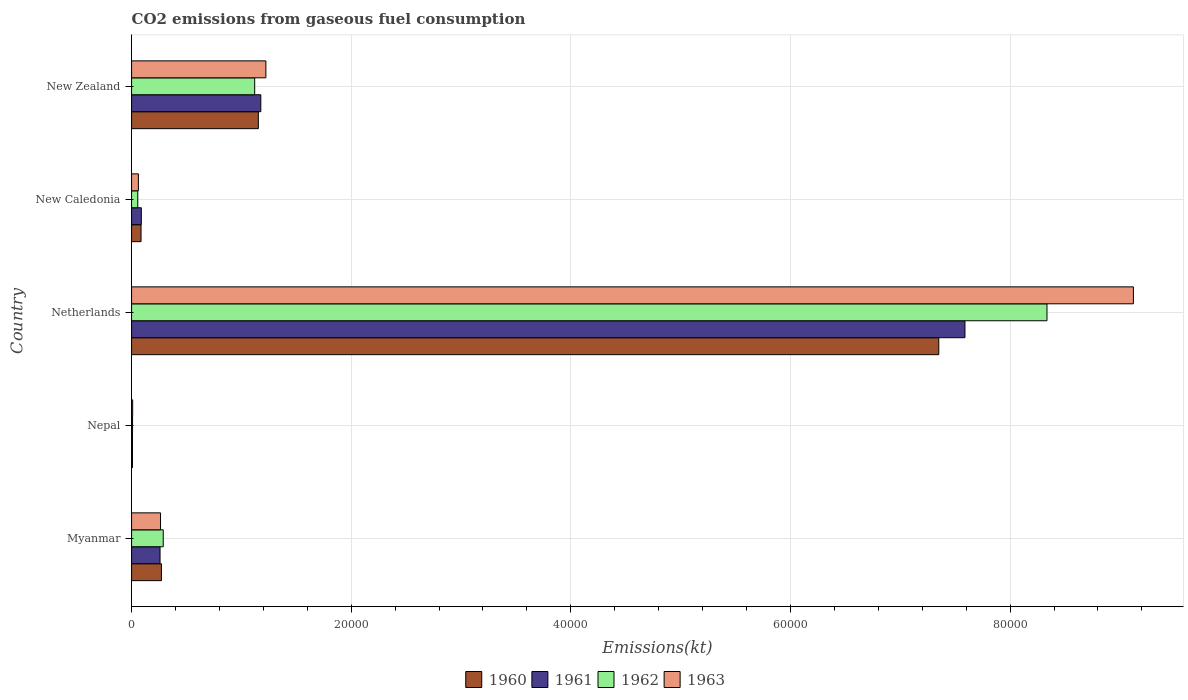How many groups of bars are there?
Ensure brevity in your answer.  5. Are the number of bars on each tick of the Y-axis equal?
Your answer should be compact. Yes. What is the label of the 4th group of bars from the top?
Offer a terse response. Nepal. What is the amount of CO2 emitted in 1963 in Nepal?
Keep it short and to the point. 99.01. Across all countries, what is the maximum amount of CO2 emitted in 1962?
Offer a very short reply. 8.34e+04. Across all countries, what is the minimum amount of CO2 emitted in 1961?
Your answer should be very brief. 80.67. In which country was the amount of CO2 emitted in 1962 maximum?
Your response must be concise. Netherlands. In which country was the amount of CO2 emitted in 1960 minimum?
Your answer should be compact. Nepal. What is the total amount of CO2 emitted in 1960 in the graph?
Your response must be concise. 8.87e+04. What is the difference between the amount of CO2 emitted in 1960 in Myanmar and that in Nepal?
Make the answer very short. 2636.57. What is the difference between the amount of CO2 emitted in 1963 in New Zealand and the amount of CO2 emitted in 1961 in New Caledonia?
Your response must be concise. 1.13e+04. What is the average amount of CO2 emitted in 1962 per country?
Offer a terse response. 1.96e+04. What is the difference between the amount of CO2 emitted in 1962 and amount of CO2 emitted in 1961 in Myanmar?
Your answer should be compact. 289.69. What is the ratio of the amount of CO2 emitted in 1961 in New Caledonia to that in New Zealand?
Provide a succinct answer. 0.08. Is the difference between the amount of CO2 emitted in 1962 in Netherlands and New Caledonia greater than the difference between the amount of CO2 emitted in 1961 in Netherlands and New Caledonia?
Your answer should be very brief. Yes. What is the difference between the highest and the second highest amount of CO2 emitted in 1963?
Your response must be concise. 7.90e+04. What is the difference between the highest and the lowest amount of CO2 emitted in 1963?
Ensure brevity in your answer.  9.11e+04. In how many countries, is the amount of CO2 emitted in 1962 greater than the average amount of CO2 emitted in 1962 taken over all countries?
Make the answer very short. 1. Is the sum of the amount of CO2 emitted in 1960 in New Caledonia and New Zealand greater than the maximum amount of CO2 emitted in 1961 across all countries?
Provide a short and direct response. No. What does the 1st bar from the bottom in New Zealand represents?
Keep it short and to the point. 1960. How many countries are there in the graph?
Make the answer very short. 5. What is the difference between two consecutive major ticks on the X-axis?
Provide a short and direct response. 2.00e+04. Does the graph contain any zero values?
Your answer should be very brief. No. How many legend labels are there?
Keep it short and to the point. 4. How are the legend labels stacked?
Provide a short and direct response. Horizontal. What is the title of the graph?
Offer a terse response. CO2 emissions from gaseous fuel consumption. What is the label or title of the X-axis?
Your response must be concise. Emissions(kt). What is the label or title of the Y-axis?
Your answer should be very brief. Country. What is the Emissions(kt) in 1960 in Myanmar?
Your response must be concise. 2717.25. What is the Emissions(kt) of 1961 in Myanmar?
Ensure brevity in your answer.  2592.57. What is the Emissions(kt) of 1962 in Myanmar?
Your answer should be compact. 2882.26. What is the Emissions(kt) of 1963 in Myanmar?
Your answer should be compact. 2636.57. What is the Emissions(kt) of 1960 in Nepal?
Provide a short and direct response. 80.67. What is the Emissions(kt) in 1961 in Nepal?
Provide a succinct answer. 80.67. What is the Emissions(kt) of 1962 in Nepal?
Your answer should be compact. 88.01. What is the Emissions(kt) of 1963 in Nepal?
Provide a short and direct response. 99.01. What is the Emissions(kt) in 1960 in Netherlands?
Your response must be concise. 7.35e+04. What is the Emissions(kt) of 1961 in Netherlands?
Provide a succinct answer. 7.59e+04. What is the Emissions(kt) of 1962 in Netherlands?
Provide a succinct answer. 8.34e+04. What is the Emissions(kt) in 1963 in Netherlands?
Provide a short and direct response. 9.12e+04. What is the Emissions(kt) of 1960 in New Caledonia?
Ensure brevity in your answer.  861.75. What is the Emissions(kt) in 1961 in New Caledonia?
Your answer should be compact. 887.41. What is the Emissions(kt) in 1962 in New Caledonia?
Offer a very short reply. 564.72. What is the Emissions(kt) of 1963 in New Caledonia?
Provide a succinct answer. 619.72. What is the Emissions(kt) in 1960 in New Zealand?
Provide a succinct answer. 1.15e+04. What is the Emissions(kt) in 1961 in New Zealand?
Your answer should be compact. 1.18e+04. What is the Emissions(kt) of 1962 in New Zealand?
Your response must be concise. 1.12e+04. What is the Emissions(kt) in 1963 in New Zealand?
Offer a very short reply. 1.22e+04. Across all countries, what is the maximum Emissions(kt) in 1960?
Give a very brief answer. 7.35e+04. Across all countries, what is the maximum Emissions(kt) of 1961?
Your answer should be very brief. 7.59e+04. Across all countries, what is the maximum Emissions(kt) of 1962?
Make the answer very short. 8.34e+04. Across all countries, what is the maximum Emissions(kt) of 1963?
Provide a short and direct response. 9.12e+04. Across all countries, what is the minimum Emissions(kt) in 1960?
Make the answer very short. 80.67. Across all countries, what is the minimum Emissions(kt) in 1961?
Your answer should be compact. 80.67. Across all countries, what is the minimum Emissions(kt) of 1962?
Offer a very short reply. 88.01. Across all countries, what is the minimum Emissions(kt) in 1963?
Ensure brevity in your answer.  99.01. What is the total Emissions(kt) of 1960 in the graph?
Your answer should be compact. 8.87e+04. What is the total Emissions(kt) of 1961 in the graph?
Your answer should be very brief. 9.12e+04. What is the total Emissions(kt) of 1962 in the graph?
Provide a short and direct response. 9.81e+04. What is the total Emissions(kt) of 1963 in the graph?
Your answer should be compact. 1.07e+05. What is the difference between the Emissions(kt) of 1960 in Myanmar and that in Nepal?
Give a very brief answer. 2636.57. What is the difference between the Emissions(kt) of 1961 in Myanmar and that in Nepal?
Ensure brevity in your answer.  2511.89. What is the difference between the Emissions(kt) in 1962 in Myanmar and that in Nepal?
Your answer should be very brief. 2794.25. What is the difference between the Emissions(kt) of 1963 in Myanmar and that in Nepal?
Your response must be concise. 2537.56. What is the difference between the Emissions(kt) in 1960 in Myanmar and that in Netherlands?
Keep it short and to the point. -7.08e+04. What is the difference between the Emissions(kt) in 1961 in Myanmar and that in Netherlands?
Ensure brevity in your answer.  -7.33e+04. What is the difference between the Emissions(kt) in 1962 in Myanmar and that in Netherlands?
Your answer should be compact. -8.05e+04. What is the difference between the Emissions(kt) of 1963 in Myanmar and that in Netherlands?
Give a very brief answer. -8.86e+04. What is the difference between the Emissions(kt) in 1960 in Myanmar and that in New Caledonia?
Offer a terse response. 1855.5. What is the difference between the Emissions(kt) in 1961 in Myanmar and that in New Caledonia?
Offer a terse response. 1705.15. What is the difference between the Emissions(kt) of 1962 in Myanmar and that in New Caledonia?
Offer a terse response. 2317.54. What is the difference between the Emissions(kt) in 1963 in Myanmar and that in New Caledonia?
Your answer should be very brief. 2016.85. What is the difference between the Emissions(kt) of 1960 in Myanmar and that in New Zealand?
Your answer should be compact. -8826.47. What is the difference between the Emissions(kt) in 1961 in Myanmar and that in New Zealand?
Your response must be concise. -9174.83. What is the difference between the Emissions(kt) of 1962 in Myanmar and that in New Zealand?
Give a very brief answer. -8327.76. What is the difference between the Emissions(kt) of 1963 in Myanmar and that in New Zealand?
Ensure brevity in your answer.  -9592.87. What is the difference between the Emissions(kt) in 1960 in Nepal and that in Netherlands?
Your response must be concise. -7.34e+04. What is the difference between the Emissions(kt) in 1961 in Nepal and that in Netherlands?
Ensure brevity in your answer.  -7.58e+04. What is the difference between the Emissions(kt) of 1962 in Nepal and that in Netherlands?
Provide a succinct answer. -8.33e+04. What is the difference between the Emissions(kt) in 1963 in Nepal and that in Netherlands?
Your answer should be very brief. -9.11e+04. What is the difference between the Emissions(kt) in 1960 in Nepal and that in New Caledonia?
Make the answer very short. -781.07. What is the difference between the Emissions(kt) of 1961 in Nepal and that in New Caledonia?
Your response must be concise. -806.74. What is the difference between the Emissions(kt) of 1962 in Nepal and that in New Caledonia?
Your response must be concise. -476.71. What is the difference between the Emissions(kt) of 1963 in Nepal and that in New Caledonia?
Your answer should be very brief. -520.71. What is the difference between the Emissions(kt) in 1960 in Nepal and that in New Zealand?
Make the answer very short. -1.15e+04. What is the difference between the Emissions(kt) of 1961 in Nepal and that in New Zealand?
Ensure brevity in your answer.  -1.17e+04. What is the difference between the Emissions(kt) of 1962 in Nepal and that in New Zealand?
Your answer should be compact. -1.11e+04. What is the difference between the Emissions(kt) of 1963 in Nepal and that in New Zealand?
Ensure brevity in your answer.  -1.21e+04. What is the difference between the Emissions(kt) of 1960 in Netherlands and that in New Caledonia?
Offer a terse response. 7.26e+04. What is the difference between the Emissions(kt) in 1961 in Netherlands and that in New Caledonia?
Give a very brief answer. 7.50e+04. What is the difference between the Emissions(kt) of 1962 in Netherlands and that in New Caledonia?
Keep it short and to the point. 8.28e+04. What is the difference between the Emissions(kt) in 1963 in Netherlands and that in New Caledonia?
Offer a terse response. 9.06e+04. What is the difference between the Emissions(kt) in 1960 in Netherlands and that in New Zealand?
Your answer should be compact. 6.20e+04. What is the difference between the Emissions(kt) in 1961 in Netherlands and that in New Zealand?
Your answer should be very brief. 6.41e+04. What is the difference between the Emissions(kt) in 1962 in Netherlands and that in New Zealand?
Provide a short and direct response. 7.21e+04. What is the difference between the Emissions(kt) of 1963 in Netherlands and that in New Zealand?
Your response must be concise. 7.90e+04. What is the difference between the Emissions(kt) in 1960 in New Caledonia and that in New Zealand?
Offer a very short reply. -1.07e+04. What is the difference between the Emissions(kt) in 1961 in New Caledonia and that in New Zealand?
Provide a succinct answer. -1.09e+04. What is the difference between the Emissions(kt) of 1962 in New Caledonia and that in New Zealand?
Offer a very short reply. -1.06e+04. What is the difference between the Emissions(kt) in 1963 in New Caledonia and that in New Zealand?
Offer a very short reply. -1.16e+04. What is the difference between the Emissions(kt) of 1960 in Myanmar and the Emissions(kt) of 1961 in Nepal?
Provide a succinct answer. 2636.57. What is the difference between the Emissions(kt) of 1960 in Myanmar and the Emissions(kt) of 1962 in Nepal?
Provide a short and direct response. 2629.24. What is the difference between the Emissions(kt) in 1960 in Myanmar and the Emissions(kt) in 1963 in Nepal?
Your answer should be compact. 2618.24. What is the difference between the Emissions(kt) in 1961 in Myanmar and the Emissions(kt) in 1962 in Nepal?
Provide a succinct answer. 2504.56. What is the difference between the Emissions(kt) of 1961 in Myanmar and the Emissions(kt) of 1963 in Nepal?
Provide a short and direct response. 2493.56. What is the difference between the Emissions(kt) in 1962 in Myanmar and the Emissions(kt) in 1963 in Nepal?
Offer a very short reply. 2783.25. What is the difference between the Emissions(kt) of 1960 in Myanmar and the Emissions(kt) of 1961 in Netherlands?
Provide a short and direct response. -7.32e+04. What is the difference between the Emissions(kt) of 1960 in Myanmar and the Emissions(kt) of 1962 in Netherlands?
Your answer should be compact. -8.06e+04. What is the difference between the Emissions(kt) of 1960 in Myanmar and the Emissions(kt) of 1963 in Netherlands?
Ensure brevity in your answer.  -8.85e+04. What is the difference between the Emissions(kt) of 1961 in Myanmar and the Emissions(kt) of 1962 in Netherlands?
Offer a terse response. -8.08e+04. What is the difference between the Emissions(kt) in 1961 in Myanmar and the Emissions(kt) in 1963 in Netherlands?
Ensure brevity in your answer.  -8.86e+04. What is the difference between the Emissions(kt) in 1962 in Myanmar and the Emissions(kt) in 1963 in Netherlands?
Make the answer very short. -8.83e+04. What is the difference between the Emissions(kt) in 1960 in Myanmar and the Emissions(kt) in 1961 in New Caledonia?
Provide a succinct answer. 1829.83. What is the difference between the Emissions(kt) in 1960 in Myanmar and the Emissions(kt) in 1962 in New Caledonia?
Offer a very short reply. 2152.53. What is the difference between the Emissions(kt) of 1960 in Myanmar and the Emissions(kt) of 1963 in New Caledonia?
Offer a very short reply. 2097.52. What is the difference between the Emissions(kt) in 1961 in Myanmar and the Emissions(kt) in 1962 in New Caledonia?
Ensure brevity in your answer.  2027.85. What is the difference between the Emissions(kt) in 1961 in Myanmar and the Emissions(kt) in 1963 in New Caledonia?
Your response must be concise. 1972.85. What is the difference between the Emissions(kt) in 1962 in Myanmar and the Emissions(kt) in 1963 in New Caledonia?
Offer a very short reply. 2262.54. What is the difference between the Emissions(kt) in 1960 in Myanmar and the Emissions(kt) in 1961 in New Zealand?
Your response must be concise. -9050.16. What is the difference between the Emissions(kt) in 1960 in Myanmar and the Emissions(kt) in 1962 in New Zealand?
Keep it short and to the point. -8492.77. What is the difference between the Emissions(kt) in 1960 in Myanmar and the Emissions(kt) in 1963 in New Zealand?
Offer a very short reply. -9512.2. What is the difference between the Emissions(kt) of 1961 in Myanmar and the Emissions(kt) of 1962 in New Zealand?
Make the answer very short. -8617.45. What is the difference between the Emissions(kt) in 1961 in Myanmar and the Emissions(kt) in 1963 in New Zealand?
Offer a very short reply. -9636.88. What is the difference between the Emissions(kt) of 1962 in Myanmar and the Emissions(kt) of 1963 in New Zealand?
Offer a very short reply. -9347.18. What is the difference between the Emissions(kt) in 1960 in Nepal and the Emissions(kt) in 1961 in Netherlands?
Your response must be concise. -7.58e+04. What is the difference between the Emissions(kt) in 1960 in Nepal and the Emissions(kt) in 1962 in Netherlands?
Your answer should be very brief. -8.33e+04. What is the difference between the Emissions(kt) of 1960 in Nepal and the Emissions(kt) of 1963 in Netherlands?
Give a very brief answer. -9.11e+04. What is the difference between the Emissions(kt) of 1961 in Nepal and the Emissions(kt) of 1962 in Netherlands?
Provide a short and direct response. -8.33e+04. What is the difference between the Emissions(kt) of 1961 in Nepal and the Emissions(kt) of 1963 in Netherlands?
Provide a succinct answer. -9.11e+04. What is the difference between the Emissions(kt) in 1962 in Nepal and the Emissions(kt) in 1963 in Netherlands?
Provide a succinct answer. -9.11e+04. What is the difference between the Emissions(kt) in 1960 in Nepal and the Emissions(kt) in 1961 in New Caledonia?
Your answer should be compact. -806.74. What is the difference between the Emissions(kt) in 1960 in Nepal and the Emissions(kt) in 1962 in New Caledonia?
Make the answer very short. -484.04. What is the difference between the Emissions(kt) in 1960 in Nepal and the Emissions(kt) in 1963 in New Caledonia?
Ensure brevity in your answer.  -539.05. What is the difference between the Emissions(kt) in 1961 in Nepal and the Emissions(kt) in 1962 in New Caledonia?
Your answer should be very brief. -484.04. What is the difference between the Emissions(kt) of 1961 in Nepal and the Emissions(kt) of 1963 in New Caledonia?
Offer a very short reply. -539.05. What is the difference between the Emissions(kt) in 1962 in Nepal and the Emissions(kt) in 1963 in New Caledonia?
Provide a succinct answer. -531.72. What is the difference between the Emissions(kt) of 1960 in Nepal and the Emissions(kt) of 1961 in New Zealand?
Offer a very short reply. -1.17e+04. What is the difference between the Emissions(kt) of 1960 in Nepal and the Emissions(kt) of 1962 in New Zealand?
Your answer should be very brief. -1.11e+04. What is the difference between the Emissions(kt) of 1960 in Nepal and the Emissions(kt) of 1963 in New Zealand?
Your response must be concise. -1.21e+04. What is the difference between the Emissions(kt) of 1961 in Nepal and the Emissions(kt) of 1962 in New Zealand?
Provide a succinct answer. -1.11e+04. What is the difference between the Emissions(kt) of 1961 in Nepal and the Emissions(kt) of 1963 in New Zealand?
Keep it short and to the point. -1.21e+04. What is the difference between the Emissions(kt) in 1962 in Nepal and the Emissions(kt) in 1963 in New Zealand?
Keep it short and to the point. -1.21e+04. What is the difference between the Emissions(kt) in 1960 in Netherlands and the Emissions(kt) in 1961 in New Caledonia?
Your response must be concise. 7.26e+04. What is the difference between the Emissions(kt) in 1960 in Netherlands and the Emissions(kt) in 1962 in New Caledonia?
Provide a succinct answer. 7.29e+04. What is the difference between the Emissions(kt) in 1960 in Netherlands and the Emissions(kt) in 1963 in New Caledonia?
Your response must be concise. 7.29e+04. What is the difference between the Emissions(kt) in 1961 in Netherlands and the Emissions(kt) in 1962 in New Caledonia?
Ensure brevity in your answer.  7.53e+04. What is the difference between the Emissions(kt) of 1961 in Netherlands and the Emissions(kt) of 1963 in New Caledonia?
Keep it short and to the point. 7.53e+04. What is the difference between the Emissions(kt) in 1962 in Netherlands and the Emissions(kt) in 1963 in New Caledonia?
Your answer should be very brief. 8.27e+04. What is the difference between the Emissions(kt) in 1960 in Netherlands and the Emissions(kt) in 1961 in New Zealand?
Offer a very short reply. 6.17e+04. What is the difference between the Emissions(kt) of 1960 in Netherlands and the Emissions(kt) of 1962 in New Zealand?
Your answer should be very brief. 6.23e+04. What is the difference between the Emissions(kt) of 1960 in Netherlands and the Emissions(kt) of 1963 in New Zealand?
Offer a very short reply. 6.13e+04. What is the difference between the Emissions(kt) in 1961 in Netherlands and the Emissions(kt) in 1962 in New Zealand?
Offer a terse response. 6.47e+04. What is the difference between the Emissions(kt) in 1961 in Netherlands and the Emissions(kt) in 1963 in New Zealand?
Your answer should be compact. 6.37e+04. What is the difference between the Emissions(kt) in 1962 in Netherlands and the Emissions(kt) in 1963 in New Zealand?
Your answer should be very brief. 7.11e+04. What is the difference between the Emissions(kt) of 1960 in New Caledonia and the Emissions(kt) of 1961 in New Zealand?
Keep it short and to the point. -1.09e+04. What is the difference between the Emissions(kt) in 1960 in New Caledonia and the Emissions(kt) in 1962 in New Zealand?
Your answer should be compact. -1.03e+04. What is the difference between the Emissions(kt) of 1960 in New Caledonia and the Emissions(kt) of 1963 in New Zealand?
Provide a succinct answer. -1.14e+04. What is the difference between the Emissions(kt) of 1961 in New Caledonia and the Emissions(kt) of 1962 in New Zealand?
Provide a succinct answer. -1.03e+04. What is the difference between the Emissions(kt) of 1961 in New Caledonia and the Emissions(kt) of 1963 in New Zealand?
Offer a very short reply. -1.13e+04. What is the difference between the Emissions(kt) in 1962 in New Caledonia and the Emissions(kt) in 1963 in New Zealand?
Make the answer very short. -1.17e+04. What is the average Emissions(kt) in 1960 per country?
Keep it short and to the point. 1.77e+04. What is the average Emissions(kt) of 1961 per country?
Offer a terse response. 1.82e+04. What is the average Emissions(kt) in 1962 per country?
Your answer should be very brief. 1.96e+04. What is the average Emissions(kt) of 1963 per country?
Provide a short and direct response. 2.14e+04. What is the difference between the Emissions(kt) of 1960 and Emissions(kt) of 1961 in Myanmar?
Offer a very short reply. 124.68. What is the difference between the Emissions(kt) in 1960 and Emissions(kt) in 1962 in Myanmar?
Make the answer very short. -165.01. What is the difference between the Emissions(kt) of 1960 and Emissions(kt) of 1963 in Myanmar?
Your answer should be very brief. 80.67. What is the difference between the Emissions(kt) in 1961 and Emissions(kt) in 1962 in Myanmar?
Offer a terse response. -289.69. What is the difference between the Emissions(kt) of 1961 and Emissions(kt) of 1963 in Myanmar?
Offer a very short reply. -44. What is the difference between the Emissions(kt) in 1962 and Emissions(kt) in 1963 in Myanmar?
Offer a very short reply. 245.69. What is the difference between the Emissions(kt) in 1960 and Emissions(kt) in 1961 in Nepal?
Offer a very short reply. 0. What is the difference between the Emissions(kt) in 1960 and Emissions(kt) in 1962 in Nepal?
Ensure brevity in your answer.  -7.33. What is the difference between the Emissions(kt) of 1960 and Emissions(kt) of 1963 in Nepal?
Provide a short and direct response. -18.34. What is the difference between the Emissions(kt) of 1961 and Emissions(kt) of 1962 in Nepal?
Give a very brief answer. -7.33. What is the difference between the Emissions(kt) of 1961 and Emissions(kt) of 1963 in Nepal?
Your response must be concise. -18.34. What is the difference between the Emissions(kt) of 1962 and Emissions(kt) of 1963 in Nepal?
Give a very brief answer. -11. What is the difference between the Emissions(kt) in 1960 and Emissions(kt) in 1961 in Netherlands?
Your response must be concise. -2383.55. What is the difference between the Emissions(kt) of 1960 and Emissions(kt) of 1962 in Netherlands?
Give a very brief answer. -9853.23. What is the difference between the Emissions(kt) in 1960 and Emissions(kt) in 1963 in Netherlands?
Provide a succinct answer. -1.77e+04. What is the difference between the Emissions(kt) of 1961 and Emissions(kt) of 1962 in Netherlands?
Your response must be concise. -7469.68. What is the difference between the Emissions(kt) of 1961 and Emissions(kt) of 1963 in Netherlands?
Give a very brief answer. -1.53e+04. What is the difference between the Emissions(kt) of 1962 and Emissions(kt) of 1963 in Netherlands?
Offer a terse response. -7869.38. What is the difference between the Emissions(kt) of 1960 and Emissions(kt) of 1961 in New Caledonia?
Ensure brevity in your answer.  -25.67. What is the difference between the Emissions(kt) of 1960 and Emissions(kt) of 1962 in New Caledonia?
Make the answer very short. 297.03. What is the difference between the Emissions(kt) in 1960 and Emissions(kt) in 1963 in New Caledonia?
Offer a very short reply. 242.02. What is the difference between the Emissions(kt) of 1961 and Emissions(kt) of 1962 in New Caledonia?
Offer a terse response. 322.7. What is the difference between the Emissions(kt) in 1961 and Emissions(kt) in 1963 in New Caledonia?
Ensure brevity in your answer.  267.69. What is the difference between the Emissions(kt) in 1962 and Emissions(kt) in 1963 in New Caledonia?
Keep it short and to the point. -55.01. What is the difference between the Emissions(kt) in 1960 and Emissions(kt) in 1961 in New Zealand?
Keep it short and to the point. -223.69. What is the difference between the Emissions(kt) in 1960 and Emissions(kt) in 1962 in New Zealand?
Provide a short and direct response. 333.7. What is the difference between the Emissions(kt) of 1960 and Emissions(kt) of 1963 in New Zealand?
Offer a terse response. -685.73. What is the difference between the Emissions(kt) in 1961 and Emissions(kt) in 1962 in New Zealand?
Make the answer very short. 557.38. What is the difference between the Emissions(kt) of 1961 and Emissions(kt) of 1963 in New Zealand?
Keep it short and to the point. -462.04. What is the difference between the Emissions(kt) in 1962 and Emissions(kt) in 1963 in New Zealand?
Ensure brevity in your answer.  -1019.43. What is the ratio of the Emissions(kt) of 1960 in Myanmar to that in Nepal?
Provide a short and direct response. 33.68. What is the ratio of the Emissions(kt) of 1961 in Myanmar to that in Nepal?
Make the answer very short. 32.14. What is the ratio of the Emissions(kt) in 1962 in Myanmar to that in Nepal?
Your response must be concise. 32.75. What is the ratio of the Emissions(kt) in 1963 in Myanmar to that in Nepal?
Your response must be concise. 26.63. What is the ratio of the Emissions(kt) in 1960 in Myanmar to that in Netherlands?
Make the answer very short. 0.04. What is the ratio of the Emissions(kt) in 1961 in Myanmar to that in Netherlands?
Ensure brevity in your answer.  0.03. What is the ratio of the Emissions(kt) in 1962 in Myanmar to that in Netherlands?
Make the answer very short. 0.03. What is the ratio of the Emissions(kt) in 1963 in Myanmar to that in Netherlands?
Keep it short and to the point. 0.03. What is the ratio of the Emissions(kt) of 1960 in Myanmar to that in New Caledonia?
Your answer should be compact. 3.15. What is the ratio of the Emissions(kt) of 1961 in Myanmar to that in New Caledonia?
Provide a short and direct response. 2.92. What is the ratio of the Emissions(kt) of 1962 in Myanmar to that in New Caledonia?
Offer a very short reply. 5.1. What is the ratio of the Emissions(kt) in 1963 in Myanmar to that in New Caledonia?
Give a very brief answer. 4.25. What is the ratio of the Emissions(kt) in 1960 in Myanmar to that in New Zealand?
Offer a terse response. 0.24. What is the ratio of the Emissions(kt) in 1961 in Myanmar to that in New Zealand?
Keep it short and to the point. 0.22. What is the ratio of the Emissions(kt) in 1962 in Myanmar to that in New Zealand?
Make the answer very short. 0.26. What is the ratio of the Emissions(kt) in 1963 in Myanmar to that in New Zealand?
Give a very brief answer. 0.22. What is the ratio of the Emissions(kt) in 1960 in Nepal to that in Netherlands?
Keep it short and to the point. 0. What is the ratio of the Emissions(kt) in 1961 in Nepal to that in Netherlands?
Your answer should be compact. 0. What is the ratio of the Emissions(kt) of 1962 in Nepal to that in Netherlands?
Provide a short and direct response. 0. What is the ratio of the Emissions(kt) of 1963 in Nepal to that in Netherlands?
Make the answer very short. 0. What is the ratio of the Emissions(kt) in 1960 in Nepal to that in New Caledonia?
Provide a short and direct response. 0.09. What is the ratio of the Emissions(kt) in 1961 in Nepal to that in New Caledonia?
Provide a succinct answer. 0.09. What is the ratio of the Emissions(kt) of 1962 in Nepal to that in New Caledonia?
Your answer should be compact. 0.16. What is the ratio of the Emissions(kt) in 1963 in Nepal to that in New Caledonia?
Provide a succinct answer. 0.16. What is the ratio of the Emissions(kt) of 1960 in Nepal to that in New Zealand?
Keep it short and to the point. 0.01. What is the ratio of the Emissions(kt) of 1961 in Nepal to that in New Zealand?
Keep it short and to the point. 0.01. What is the ratio of the Emissions(kt) of 1962 in Nepal to that in New Zealand?
Offer a very short reply. 0.01. What is the ratio of the Emissions(kt) in 1963 in Nepal to that in New Zealand?
Your answer should be compact. 0.01. What is the ratio of the Emissions(kt) in 1960 in Netherlands to that in New Caledonia?
Keep it short and to the point. 85.3. What is the ratio of the Emissions(kt) in 1961 in Netherlands to that in New Caledonia?
Your answer should be compact. 85.52. What is the ratio of the Emissions(kt) of 1962 in Netherlands to that in New Caledonia?
Your answer should be very brief. 147.61. What is the ratio of the Emissions(kt) in 1963 in Netherlands to that in New Caledonia?
Your response must be concise. 147.21. What is the ratio of the Emissions(kt) in 1960 in Netherlands to that in New Zealand?
Provide a short and direct response. 6.37. What is the ratio of the Emissions(kt) of 1961 in Netherlands to that in New Zealand?
Provide a succinct answer. 6.45. What is the ratio of the Emissions(kt) in 1962 in Netherlands to that in New Zealand?
Give a very brief answer. 7.44. What is the ratio of the Emissions(kt) of 1963 in Netherlands to that in New Zealand?
Keep it short and to the point. 7.46. What is the ratio of the Emissions(kt) of 1960 in New Caledonia to that in New Zealand?
Offer a terse response. 0.07. What is the ratio of the Emissions(kt) in 1961 in New Caledonia to that in New Zealand?
Your answer should be compact. 0.08. What is the ratio of the Emissions(kt) in 1962 in New Caledonia to that in New Zealand?
Provide a short and direct response. 0.05. What is the ratio of the Emissions(kt) of 1963 in New Caledonia to that in New Zealand?
Provide a succinct answer. 0.05. What is the difference between the highest and the second highest Emissions(kt) of 1960?
Give a very brief answer. 6.20e+04. What is the difference between the highest and the second highest Emissions(kt) in 1961?
Your response must be concise. 6.41e+04. What is the difference between the highest and the second highest Emissions(kt) in 1962?
Offer a very short reply. 7.21e+04. What is the difference between the highest and the second highest Emissions(kt) of 1963?
Provide a succinct answer. 7.90e+04. What is the difference between the highest and the lowest Emissions(kt) in 1960?
Ensure brevity in your answer.  7.34e+04. What is the difference between the highest and the lowest Emissions(kt) of 1961?
Keep it short and to the point. 7.58e+04. What is the difference between the highest and the lowest Emissions(kt) in 1962?
Your answer should be compact. 8.33e+04. What is the difference between the highest and the lowest Emissions(kt) in 1963?
Provide a short and direct response. 9.11e+04. 